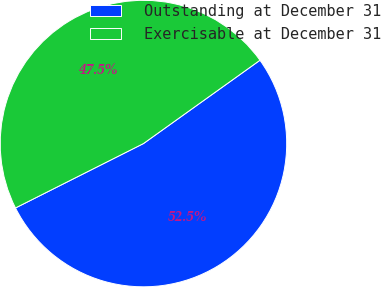<chart> <loc_0><loc_0><loc_500><loc_500><pie_chart><fcel>Outstanding at December 31<fcel>Exercisable at December 31<nl><fcel>52.46%<fcel>47.54%<nl></chart> 